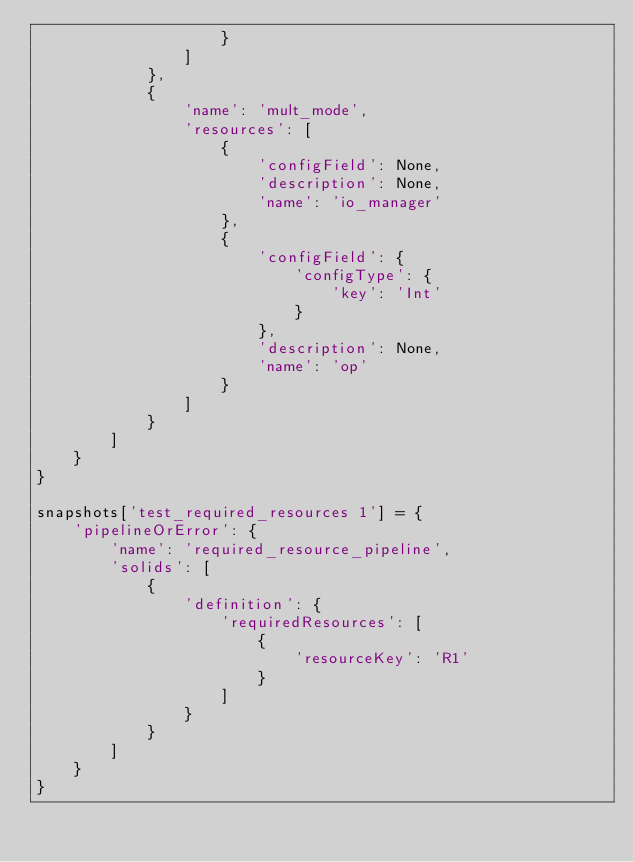<code> <loc_0><loc_0><loc_500><loc_500><_Python_>                    }
                ]
            },
            {
                'name': 'mult_mode',
                'resources': [
                    {
                        'configField': None,
                        'description': None,
                        'name': 'io_manager'
                    },
                    {
                        'configField': {
                            'configType': {
                                'key': 'Int'
                            }
                        },
                        'description': None,
                        'name': 'op'
                    }
                ]
            }
        ]
    }
}

snapshots['test_required_resources 1'] = {
    'pipelineOrError': {
        'name': 'required_resource_pipeline',
        'solids': [
            {
                'definition': {
                    'requiredResources': [
                        {
                            'resourceKey': 'R1'
                        }
                    ]
                }
            }
        ]
    }
}
</code> 